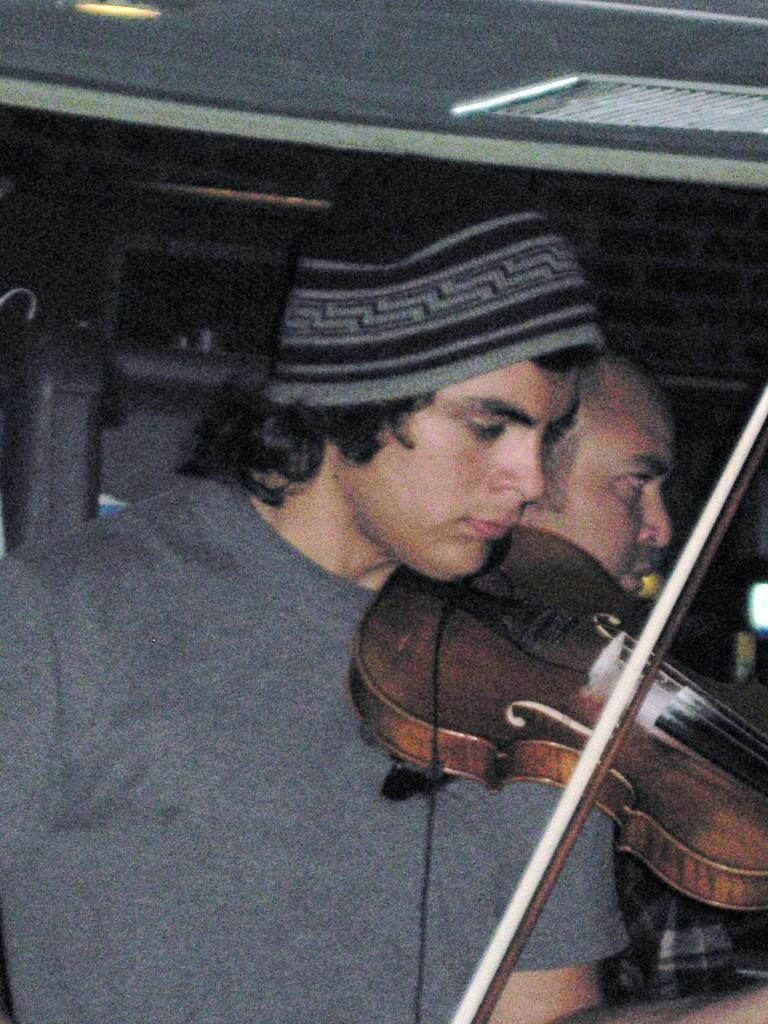What is the person in the image holding? The person is holding a musical instrument in the image. Can you describe the person's attire? The person is wearing a cap. Is there anyone else visible in the image? Yes, there is a man visible in the background of the image. How many books can be seen on the carriage in the image? There is no carriage or books present in the image. 